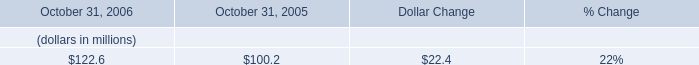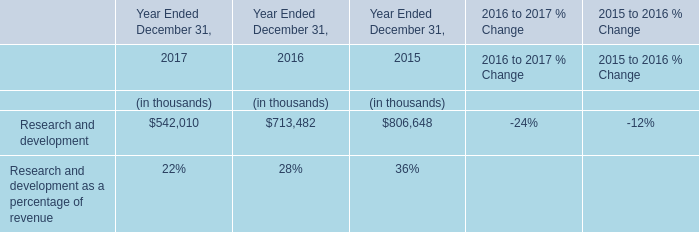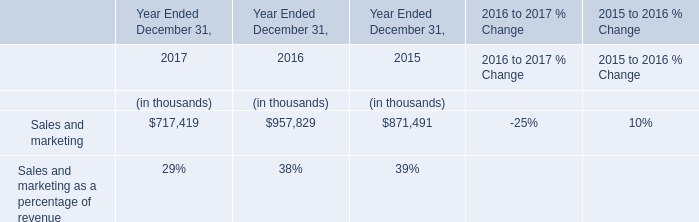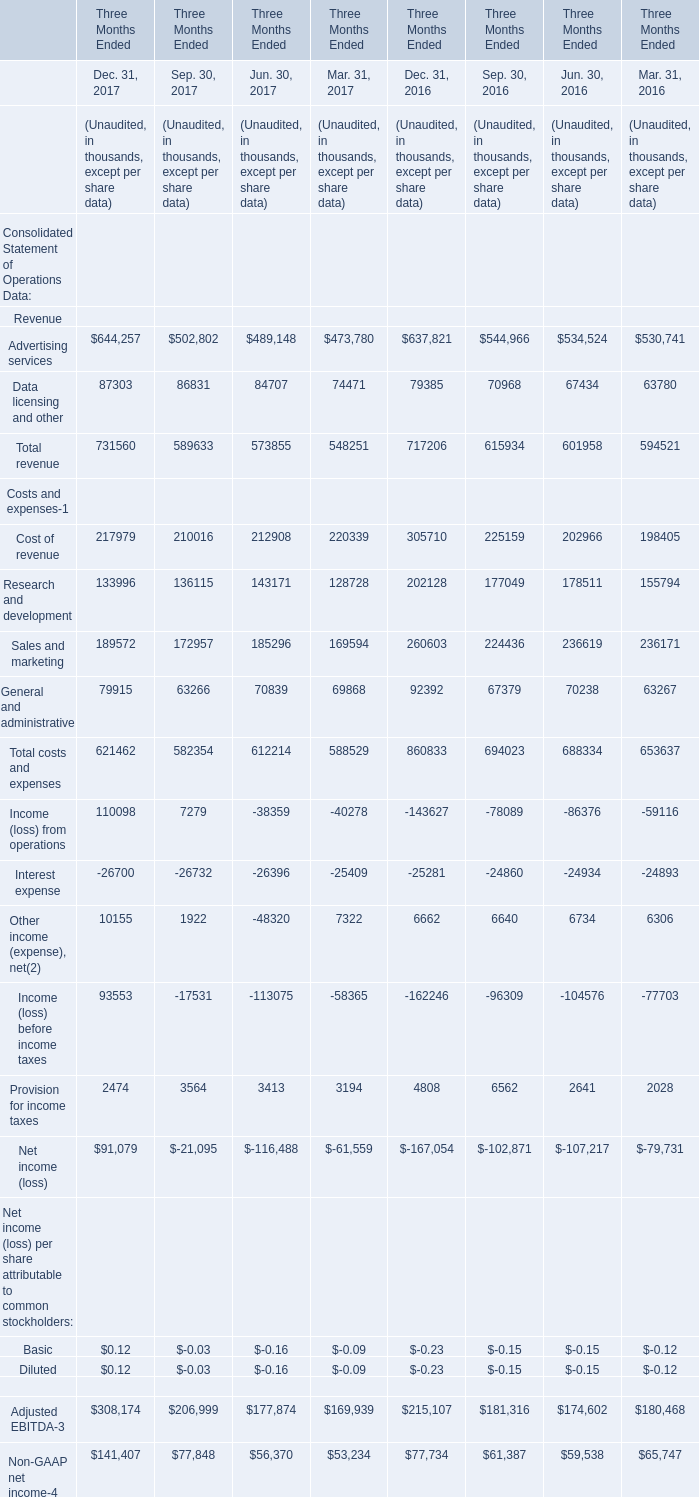As As the chart 3 shows,in quarter what of 2017 is Total revenue Unaudited greater than 700000 thousand? 
Answer: 4. 